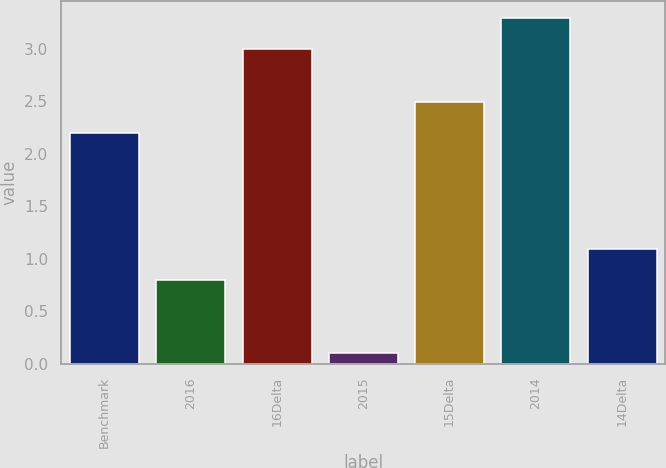Convert chart to OTSL. <chart><loc_0><loc_0><loc_500><loc_500><bar_chart><fcel>Benchmark<fcel>2016<fcel>16Delta<fcel>2015<fcel>15Delta<fcel>2014<fcel>14Delta<nl><fcel>2.2<fcel>0.8<fcel>3<fcel>0.1<fcel>2.49<fcel>3.29<fcel>1.09<nl></chart> 